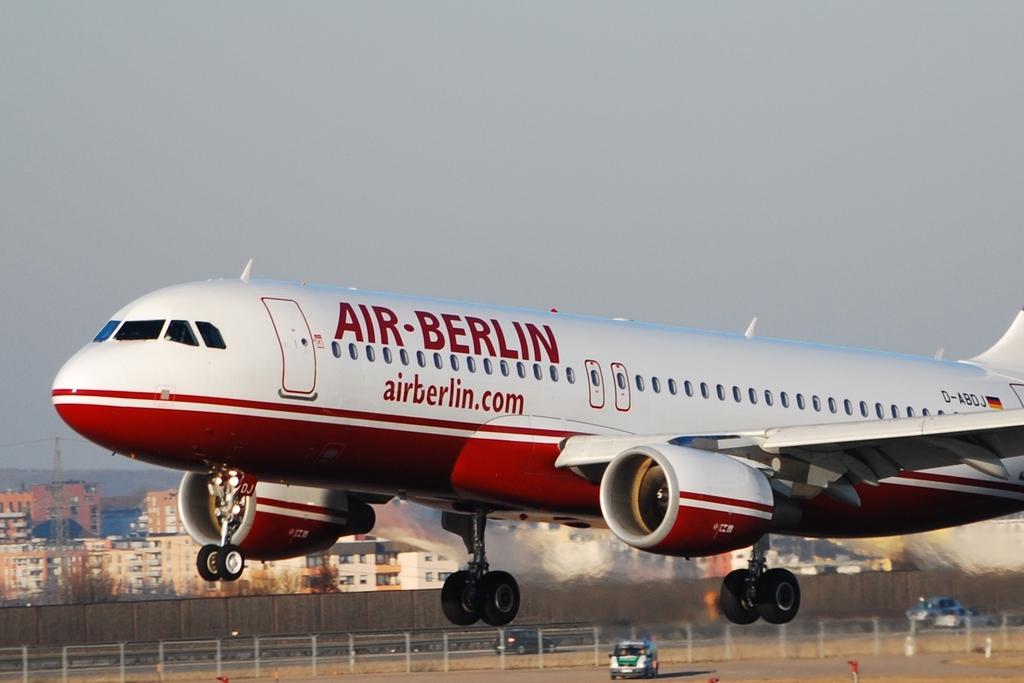What's the web address printed on the plane?
Ensure brevity in your answer.  Airberlin.com. What is the airline?
Give a very brief answer. Air berlin. 